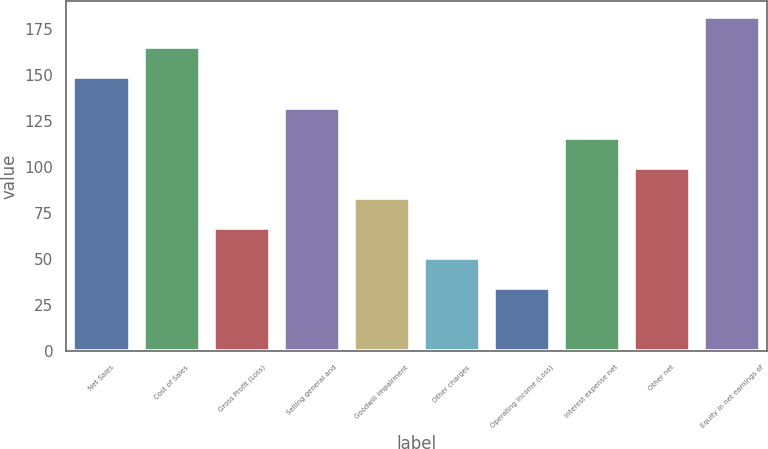Convert chart. <chart><loc_0><loc_0><loc_500><loc_500><bar_chart><fcel>Net Sales<fcel>Cost of Sales<fcel>Gross Profit (Loss)<fcel>Selling general and<fcel>Goodwill impairment<fcel>Other charges<fcel>Operating Income (Loss)<fcel>Interest expense net<fcel>Other net<fcel>Equity in net earnings of<nl><fcel>148.7<fcel>165.04<fcel>67<fcel>132.36<fcel>83.34<fcel>50.66<fcel>34.32<fcel>116.02<fcel>99.68<fcel>181.38<nl></chart> 